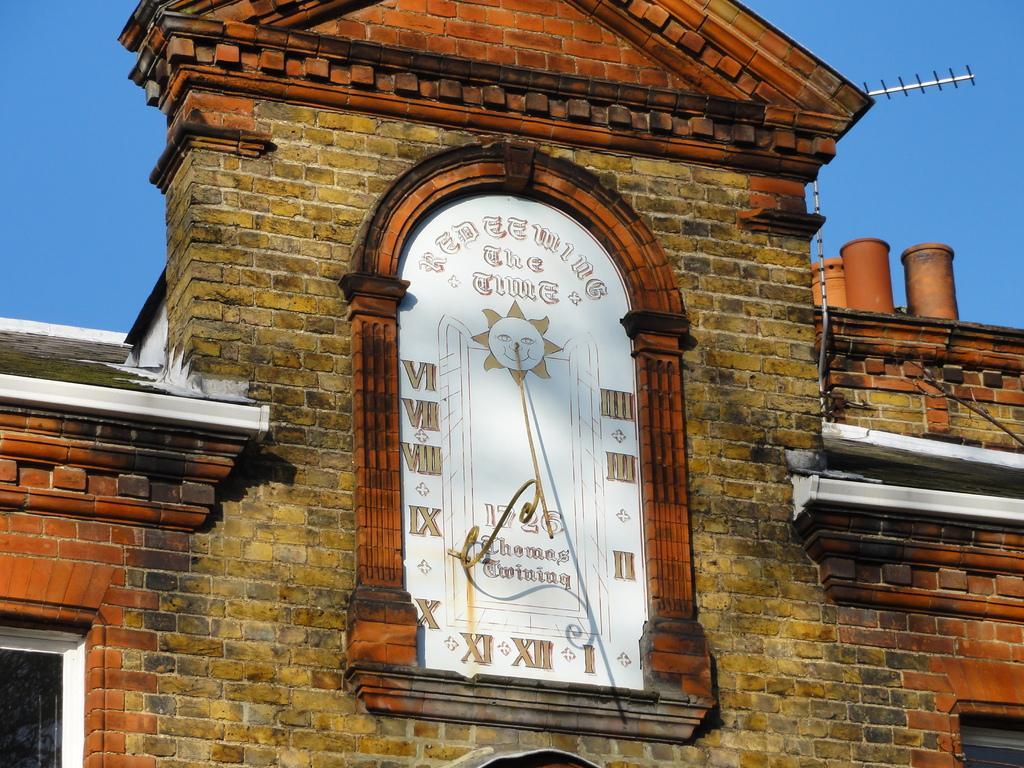<image>
Relay a brief, clear account of the picture shown. A building has a built-in old clock with the date 1726 on the face. 